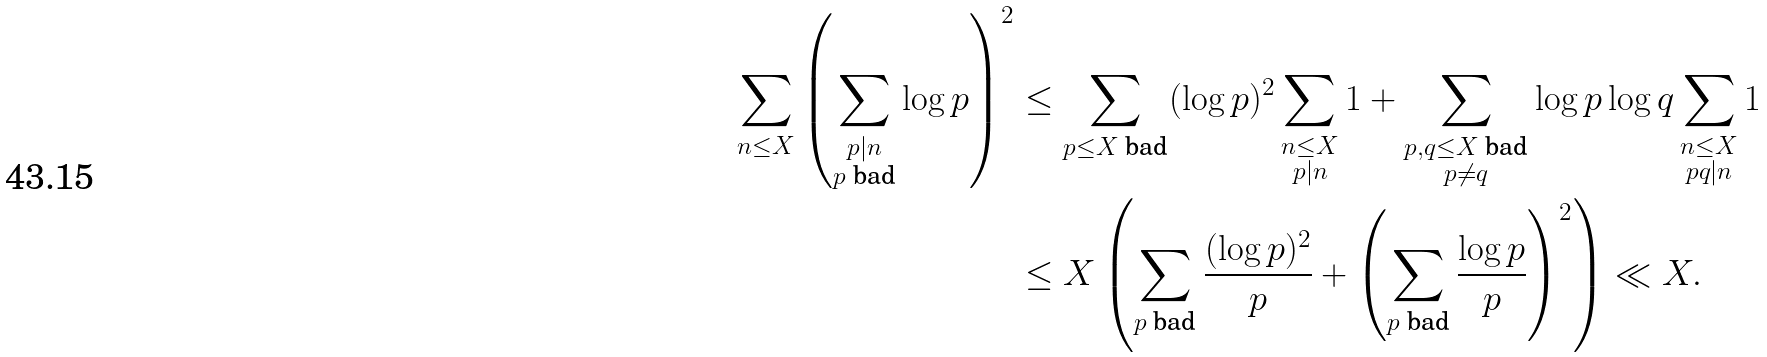<formula> <loc_0><loc_0><loc_500><loc_500>\sum _ { n \leq X } \left ( \sum _ { \substack { p | n \\ p \text { bad} } } \log { p } \right ) ^ { 2 } & \leq \sum _ { p \leq X \text { bad} } ( \log { p } ) ^ { 2 } \sum _ { \substack { n \leq X \\ p | n } } 1 + \sum _ { \substack { p , q \leq X \text { bad} \\ p \ne q } } \log { p } \log { q } \sum _ { \substack { n \leq X \\ p q | n } } 1 \\ & \leq X \left ( \sum _ { p \text { bad} } \frac { ( \log { p } ) ^ { 2 } } { p } + \left ( \sum _ { p \text { bad} } \frac { \log { p } } { p } \right ) ^ { 2 } \right ) \ll X .</formula> 